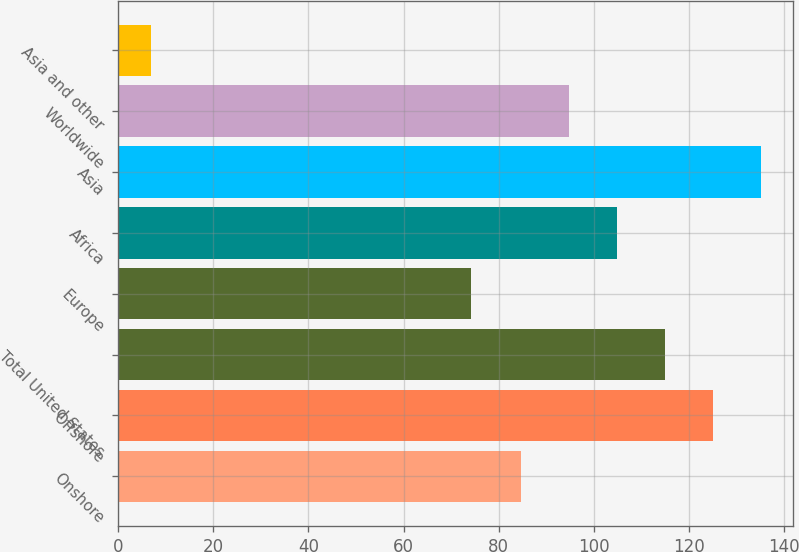Convert chart. <chart><loc_0><loc_0><loc_500><loc_500><bar_chart><fcel>Onshore<fcel>Offshore<fcel>Total United States<fcel>Europe<fcel>Africa<fcel>Asia<fcel>Worldwide<fcel>Asia and other<nl><fcel>84.78<fcel>125.01<fcel>114.96<fcel>74.14<fcel>104.9<fcel>135.06<fcel>94.84<fcel>6.9<nl></chart> 